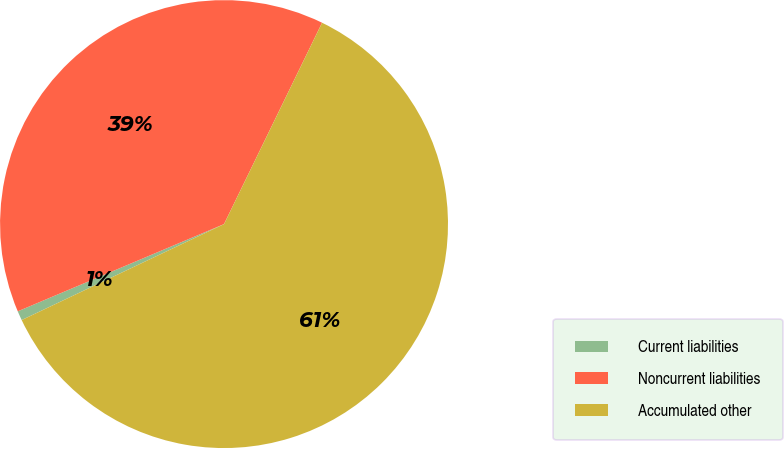<chart> <loc_0><loc_0><loc_500><loc_500><pie_chart><fcel>Current liabilities<fcel>Noncurrent liabilities<fcel>Accumulated other<nl><fcel>0.68%<fcel>38.58%<fcel>60.74%<nl></chart> 